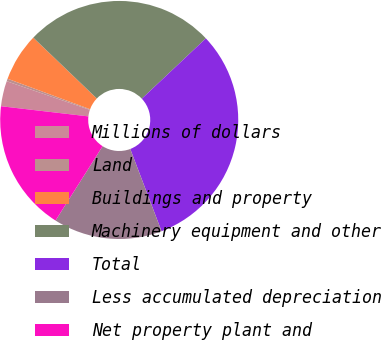<chart> <loc_0><loc_0><loc_500><loc_500><pie_chart><fcel>Millions of dollars<fcel>Land<fcel>Buildings and property<fcel>Machinery equipment and other<fcel>Total<fcel>Less accumulated depreciation<fcel>Net property plant and<nl><fcel>3.44%<fcel>0.35%<fcel>6.53%<fcel>25.82%<fcel>31.24%<fcel>14.77%<fcel>17.86%<nl></chart> 